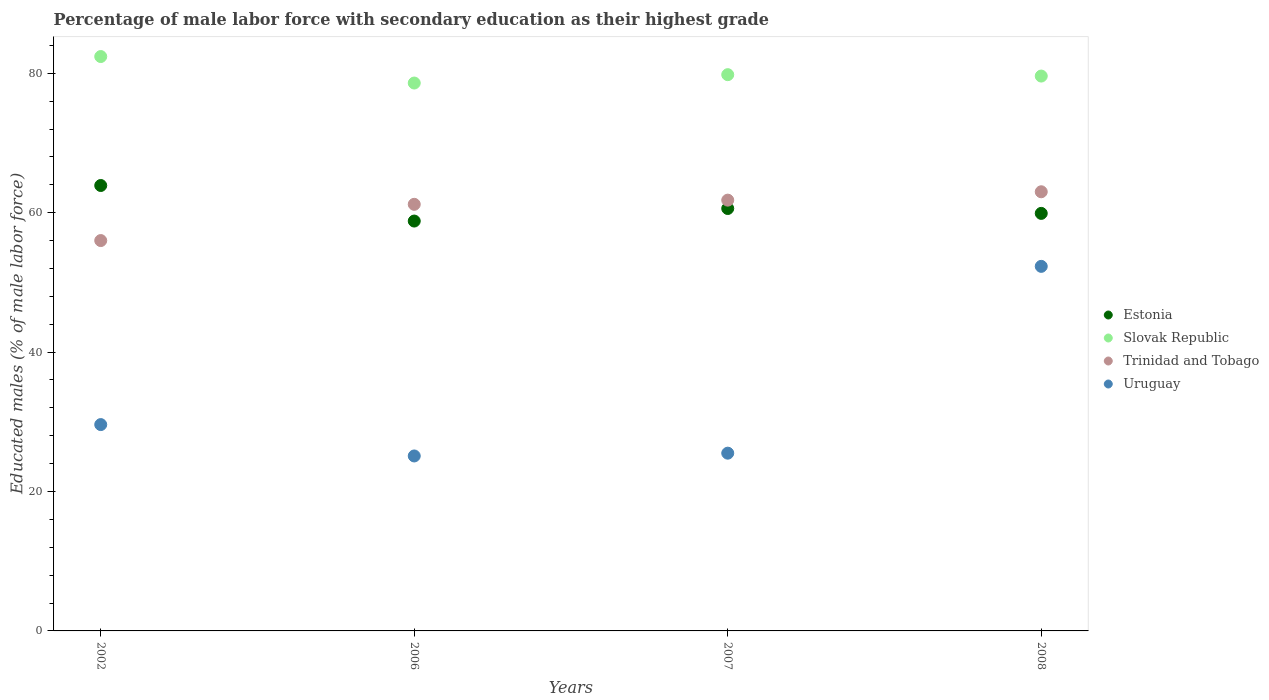How many different coloured dotlines are there?
Your response must be concise. 4. Is the number of dotlines equal to the number of legend labels?
Provide a short and direct response. Yes. What is the percentage of male labor force with secondary education in Uruguay in 2006?
Your response must be concise. 25.1. Across all years, what is the maximum percentage of male labor force with secondary education in Slovak Republic?
Give a very brief answer. 82.4. Across all years, what is the minimum percentage of male labor force with secondary education in Slovak Republic?
Make the answer very short. 78.6. In which year was the percentage of male labor force with secondary education in Trinidad and Tobago minimum?
Provide a short and direct response. 2002. What is the total percentage of male labor force with secondary education in Trinidad and Tobago in the graph?
Provide a short and direct response. 242. What is the difference between the percentage of male labor force with secondary education in Slovak Republic in 2002 and that in 2008?
Your response must be concise. 2.8. What is the difference between the percentage of male labor force with secondary education in Slovak Republic in 2006 and the percentage of male labor force with secondary education in Trinidad and Tobago in 2002?
Keep it short and to the point. 22.6. What is the average percentage of male labor force with secondary education in Uruguay per year?
Provide a short and direct response. 33.12. In the year 2007, what is the difference between the percentage of male labor force with secondary education in Slovak Republic and percentage of male labor force with secondary education in Estonia?
Make the answer very short. 19.2. In how many years, is the percentage of male labor force with secondary education in Estonia greater than 56 %?
Your answer should be very brief. 4. What is the ratio of the percentage of male labor force with secondary education in Uruguay in 2006 to that in 2007?
Ensure brevity in your answer.  0.98. Is the percentage of male labor force with secondary education in Trinidad and Tobago in 2002 less than that in 2008?
Ensure brevity in your answer.  Yes. Is the difference between the percentage of male labor force with secondary education in Slovak Republic in 2002 and 2007 greater than the difference between the percentage of male labor force with secondary education in Estonia in 2002 and 2007?
Provide a short and direct response. No. What is the difference between the highest and the second highest percentage of male labor force with secondary education in Trinidad and Tobago?
Make the answer very short. 1.2. What is the difference between the highest and the lowest percentage of male labor force with secondary education in Estonia?
Provide a succinct answer. 5.1. Is it the case that in every year, the sum of the percentage of male labor force with secondary education in Estonia and percentage of male labor force with secondary education in Trinidad and Tobago  is greater than the sum of percentage of male labor force with secondary education in Slovak Republic and percentage of male labor force with secondary education in Uruguay?
Keep it short and to the point. No. Is the percentage of male labor force with secondary education in Uruguay strictly less than the percentage of male labor force with secondary education in Estonia over the years?
Give a very brief answer. Yes. What is the difference between two consecutive major ticks on the Y-axis?
Provide a succinct answer. 20. Does the graph contain any zero values?
Your response must be concise. No. Does the graph contain grids?
Your response must be concise. No. Where does the legend appear in the graph?
Keep it short and to the point. Center right. How many legend labels are there?
Make the answer very short. 4. How are the legend labels stacked?
Provide a short and direct response. Vertical. What is the title of the graph?
Ensure brevity in your answer.  Percentage of male labor force with secondary education as their highest grade. What is the label or title of the Y-axis?
Keep it short and to the point. Educated males (% of male labor force). What is the Educated males (% of male labor force) in Estonia in 2002?
Your response must be concise. 63.9. What is the Educated males (% of male labor force) in Slovak Republic in 2002?
Your response must be concise. 82.4. What is the Educated males (% of male labor force) in Uruguay in 2002?
Give a very brief answer. 29.6. What is the Educated males (% of male labor force) in Estonia in 2006?
Your response must be concise. 58.8. What is the Educated males (% of male labor force) of Slovak Republic in 2006?
Provide a succinct answer. 78.6. What is the Educated males (% of male labor force) of Trinidad and Tobago in 2006?
Offer a very short reply. 61.2. What is the Educated males (% of male labor force) in Uruguay in 2006?
Offer a very short reply. 25.1. What is the Educated males (% of male labor force) in Estonia in 2007?
Offer a very short reply. 60.6. What is the Educated males (% of male labor force) of Slovak Republic in 2007?
Offer a very short reply. 79.8. What is the Educated males (% of male labor force) of Trinidad and Tobago in 2007?
Offer a terse response. 61.8. What is the Educated males (% of male labor force) in Uruguay in 2007?
Ensure brevity in your answer.  25.5. What is the Educated males (% of male labor force) of Estonia in 2008?
Offer a very short reply. 59.9. What is the Educated males (% of male labor force) in Slovak Republic in 2008?
Provide a succinct answer. 79.6. What is the Educated males (% of male labor force) in Trinidad and Tobago in 2008?
Give a very brief answer. 63. What is the Educated males (% of male labor force) of Uruguay in 2008?
Make the answer very short. 52.3. Across all years, what is the maximum Educated males (% of male labor force) of Estonia?
Give a very brief answer. 63.9. Across all years, what is the maximum Educated males (% of male labor force) in Slovak Republic?
Give a very brief answer. 82.4. Across all years, what is the maximum Educated males (% of male labor force) in Uruguay?
Provide a short and direct response. 52.3. Across all years, what is the minimum Educated males (% of male labor force) of Estonia?
Provide a short and direct response. 58.8. Across all years, what is the minimum Educated males (% of male labor force) of Slovak Republic?
Your answer should be compact. 78.6. Across all years, what is the minimum Educated males (% of male labor force) of Uruguay?
Your answer should be very brief. 25.1. What is the total Educated males (% of male labor force) of Estonia in the graph?
Provide a succinct answer. 243.2. What is the total Educated males (% of male labor force) of Slovak Republic in the graph?
Make the answer very short. 320.4. What is the total Educated males (% of male labor force) in Trinidad and Tobago in the graph?
Provide a succinct answer. 242. What is the total Educated males (% of male labor force) in Uruguay in the graph?
Offer a terse response. 132.5. What is the difference between the Educated males (% of male labor force) of Slovak Republic in 2002 and that in 2007?
Provide a succinct answer. 2.6. What is the difference between the Educated males (% of male labor force) in Uruguay in 2002 and that in 2007?
Your answer should be compact. 4.1. What is the difference between the Educated males (% of male labor force) in Slovak Republic in 2002 and that in 2008?
Provide a short and direct response. 2.8. What is the difference between the Educated males (% of male labor force) of Uruguay in 2002 and that in 2008?
Your response must be concise. -22.7. What is the difference between the Educated males (% of male labor force) in Estonia in 2006 and that in 2007?
Ensure brevity in your answer.  -1.8. What is the difference between the Educated males (% of male labor force) in Slovak Republic in 2006 and that in 2007?
Give a very brief answer. -1.2. What is the difference between the Educated males (% of male labor force) of Estonia in 2006 and that in 2008?
Make the answer very short. -1.1. What is the difference between the Educated males (% of male labor force) in Trinidad and Tobago in 2006 and that in 2008?
Provide a succinct answer. -1.8. What is the difference between the Educated males (% of male labor force) of Uruguay in 2006 and that in 2008?
Your answer should be very brief. -27.2. What is the difference between the Educated males (% of male labor force) in Slovak Republic in 2007 and that in 2008?
Offer a very short reply. 0.2. What is the difference between the Educated males (% of male labor force) in Trinidad and Tobago in 2007 and that in 2008?
Provide a succinct answer. -1.2. What is the difference between the Educated males (% of male labor force) of Uruguay in 2007 and that in 2008?
Make the answer very short. -26.8. What is the difference between the Educated males (% of male labor force) of Estonia in 2002 and the Educated males (% of male labor force) of Slovak Republic in 2006?
Provide a short and direct response. -14.7. What is the difference between the Educated males (% of male labor force) in Estonia in 2002 and the Educated males (% of male labor force) in Trinidad and Tobago in 2006?
Offer a very short reply. 2.7. What is the difference between the Educated males (% of male labor force) in Estonia in 2002 and the Educated males (% of male labor force) in Uruguay in 2006?
Provide a short and direct response. 38.8. What is the difference between the Educated males (% of male labor force) in Slovak Republic in 2002 and the Educated males (% of male labor force) in Trinidad and Tobago in 2006?
Keep it short and to the point. 21.2. What is the difference between the Educated males (% of male labor force) of Slovak Republic in 2002 and the Educated males (% of male labor force) of Uruguay in 2006?
Your response must be concise. 57.3. What is the difference between the Educated males (% of male labor force) in Trinidad and Tobago in 2002 and the Educated males (% of male labor force) in Uruguay in 2006?
Ensure brevity in your answer.  30.9. What is the difference between the Educated males (% of male labor force) of Estonia in 2002 and the Educated males (% of male labor force) of Slovak Republic in 2007?
Ensure brevity in your answer.  -15.9. What is the difference between the Educated males (% of male labor force) in Estonia in 2002 and the Educated males (% of male labor force) in Uruguay in 2007?
Make the answer very short. 38.4. What is the difference between the Educated males (% of male labor force) in Slovak Republic in 2002 and the Educated males (% of male labor force) in Trinidad and Tobago in 2007?
Your answer should be very brief. 20.6. What is the difference between the Educated males (% of male labor force) in Slovak Republic in 2002 and the Educated males (% of male labor force) in Uruguay in 2007?
Your response must be concise. 56.9. What is the difference between the Educated males (% of male labor force) in Trinidad and Tobago in 2002 and the Educated males (% of male labor force) in Uruguay in 2007?
Your response must be concise. 30.5. What is the difference between the Educated males (% of male labor force) of Estonia in 2002 and the Educated males (% of male labor force) of Slovak Republic in 2008?
Offer a terse response. -15.7. What is the difference between the Educated males (% of male labor force) in Estonia in 2002 and the Educated males (% of male labor force) in Trinidad and Tobago in 2008?
Your answer should be very brief. 0.9. What is the difference between the Educated males (% of male labor force) in Estonia in 2002 and the Educated males (% of male labor force) in Uruguay in 2008?
Your answer should be compact. 11.6. What is the difference between the Educated males (% of male labor force) of Slovak Republic in 2002 and the Educated males (% of male labor force) of Uruguay in 2008?
Your response must be concise. 30.1. What is the difference between the Educated males (% of male labor force) of Trinidad and Tobago in 2002 and the Educated males (% of male labor force) of Uruguay in 2008?
Make the answer very short. 3.7. What is the difference between the Educated males (% of male labor force) in Estonia in 2006 and the Educated males (% of male labor force) in Slovak Republic in 2007?
Make the answer very short. -21. What is the difference between the Educated males (% of male labor force) in Estonia in 2006 and the Educated males (% of male labor force) in Trinidad and Tobago in 2007?
Offer a terse response. -3. What is the difference between the Educated males (% of male labor force) of Estonia in 2006 and the Educated males (% of male labor force) of Uruguay in 2007?
Your answer should be very brief. 33.3. What is the difference between the Educated males (% of male labor force) in Slovak Republic in 2006 and the Educated males (% of male labor force) in Trinidad and Tobago in 2007?
Offer a very short reply. 16.8. What is the difference between the Educated males (% of male labor force) in Slovak Republic in 2006 and the Educated males (% of male labor force) in Uruguay in 2007?
Offer a very short reply. 53.1. What is the difference between the Educated males (% of male labor force) in Trinidad and Tobago in 2006 and the Educated males (% of male labor force) in Uruguay in 2007?
Give a very brief answer. 35.7. What is the difference between the Educated males (% of male labor force) in Estonia in 2006 and the Educated males (% of male labor force) in Slovak Republic in 2008?
Provide a succinct answer. -20.8. What is the difference between the Educated males (% of male labor force) in Estonia in 2006 and the Educated males (% of male labor force) in Uruguay in 2008?
Give a very brief answer. 6.5. What is the difference between the Educated males (% of male labor force) of Slovak Republic in 2006 and the Educated males (% of male labor force) of Trinidad and Tobago in 2008?
Ensure brevity in your answer.  15.6. What is the difference between the Educated males (% of male labor force) in Slovak Republic in 2006 and the Educated males (% of male labor force) in Uruguay in 2008?
Ensure brevity in your answer.  26.3. What is the difference between the Educated males (% of male labor force) of Trinidad and Tobago in 2006 and the Educated males (% of male labor force) of Uruguay in 2008?
Ensure brevity in your answer.  8.9. What is the difference between the Educated males (% of male labor force) in Estonia in 2007 and the Educated males (% of male labor force) in Slovak Republic in 2008?
Ensure brevity in your answer.  -19. What is the difference between the Educated males (% of male labor force) of Estonia in 2007 and the Educated males (% of male labor force) of Trinidad and Tobago in 2008?
Keep it short and to the point. -2.4. What is the difference between the Educated males (% of male labor force) of Estonia in 2007 and the Educated males (% of male labor force) of Uruguay in 2008?
Offer a very short reply. 8.3. What is the difference between the Educated males (% of male labor force) of Slovak Republic in 2007 and the Educated males (% of male labor force) of Trinidad and Tobago in 2008?
Your answer should be compact. 16.8. What is the difference between the Educated males (% of male labor force) in Slovak Republic in 2007 and the Educated males (% of male labor force) in Uruguay in 2008?
Ensure brevity in your answer.  27.5. What is the average Educated males (% of male labor force) of Estonia per year?
Give a very brief answer. 60.8. What is the average Educated males (% of male labor force) in Slovak Republic per year?
Provide a short and direct response. 80.1. What is the average Educated males (% of male labor force) in Trinidad and Tobago per year?
Your response must be concise. 60.5. What is the average Educated males (% of male labor force) of Uruguay per year?
Your answer should be very brief. 33.12. In the year 2002, what is the difference between the Educated males (% of male labor force) in Estonia and Educated males (% of male labor force) in Slovak Republic?
Offer a very short reply. -18.5. In the year 2002, what is the difference between the Educated males (% of male labor force) of Estonia and Educated males (% of male labor force) of Uruguay?
Your answer should be very brief. 34.3. In the year 2002, what is the difference between the Educated males (% of male labor force) in Slovak Republic and Educated males (% of male labor force) in Trinidad and Tobago?
Make the answer very short. 26.4. In the year 2002, what is the difference between the Educated males (% of male labor force) of Slovak Republic and Educated males (% of male labor force) of Uruguay?
Your answer should be compact. 52.8. In the year 2002, what is the difference between the Educated males (% of male labor force) of Trinidad and Tobago and Educated males (% of male labor force) of Uruguay?
Keep it short and to the point. 26.4. In the year 2006, what is the difference between the Educated males (% of male labor force) in Estonia and Educated males (% of male labor force) in Slovak Republic?
Ensure brevity in your answer.  -19.8. In the year 2006, what is the difference between the Educated males (% of male labor force) of Estonia and Educated males (% of male labor force) of Trinidad and Tobago?
Your response must be concise. -2.4. In the year 2006, what is the difference between the Educated males (% of male labor force) in Estonia and Educated males (% of male labor force) in Uruguay?
Make the answer very short. 33.7. In the year 2006, what is the difference between the Educated males (% of male labor force) in Slovak Republic and Educated males (% of male labor force) in Uruguay?
Give a very brief answer. 53.5. In the year 2006, what is the difference between the Educated males (% of male labor force) in Trinidad and Tobago and Educated males (% of male labor force) in Uruguay?
Keep it short and to the point. 36.1. In the year 2007, what is the difference between the Educated males (% of male labor force) of Estonia and Educated males (% of male labor force) of Slovak Republic?
Your response must be concise. -19.2. In the year 2007, what is the difference between the Educated males (% of male labor force) in Estonia and Educated males (% of male labor force) in Uruguay?
Your answer should be compact. 35.1. In the year 2007, what is the difference between the Educated males (% of male labor force) of Slovak Republic and Educated males (% of male labor force) of Uruguay?
Provide a succinct answer. 54.3. In the year 2007, what is the difference between the Educated males (% of male labor force) of Trinidad and Tobago and Educated males (% of male labor force) of Uruguay?
Provide a short and direct response. 36.3. In the year 2008, what is the difference between the Educated males (% of male labor force) in Estonia and Educated males (% of male labor force) in Slovak Republic?
Ensure brevity in your answer.  -19.7. In the year 2008, what is the difference between the Educated males (% of male labor force) in Estonia and Educated males (% of male labor force) in Trinidad and Tobago?
Your response must be concise. -3.1. In the year 2008, what is the difference between the Educated males (% of male labor force) of Slovak Republic and Educated males (% of male labor force) of Uruguay?
Provide a succinct answer. 27.3. What is the ratio of the Educated males (% of male labor force) in Estonia in 2002 to that in 2006?
Give a very brief answer. 1.09. What is the ratio of the Educated males (% of male labor force) in Slovak Republic in 2002 to that in 2006?
Your answer should be compact. 1.05. What is the ratio of the Educated males (% of male labor force) in Trinidad and Tobago in 2002 to that in 2006?
Make the answer very short. 0.92. What is the ratio of the Educated males (% of male labor force) in Uruguay in 2002 to that in 2006?
Ensure brevity in your answer.  1.18. What is the ratio of the Educated males (% of male labor force) in Estonia in 2002 to that in 2007?
Make the answer very short. 1.05. What is the ratio of the Educated males (% of male labor force) of Slovak Republic in 2002 to that in 2007?
Make the answer very short. 1.03. What is the ratio of the Educated males (% of male labor force) in Trinidad and Tobago in 2002 to that in 2007?
Give a very brief answer. 0.91. What is the ratio of the Educated males (% of male labor force) of Uruguay in 2002 to that in 2007?
Provide a succinct answer. 1.16. What is the ratio of the Educated males (% of male labor force) of Estonia in 2002 to that in 2008?
Make the answer very short. 1.07. What is the ratio of the Educated males (% of male labor force) in Slovak Republic in 2002 to that in 2008?
Your response must be concise. 1.04. What is the ratio of the Educated males (% of male labor force) of Uruguay in 2002 to that in 2008?
Your answer should be very brief. 0.57. What is the ratio of the Educated males (% of male labor force) in Estonia in 2006 to that in 2007?
Offer a terse response. 0.97. What is the ratio of the Educated males (% of male labor force) of Trinidad and Tobago in 2006 to that in 2007?
Keep it short and to the point. 0.99. What is the ratio of the Educated males (% of male labor force) in Uruguay in 2006 to that in 2007?
Your response must be concise. 0.98. What is the ratio of the Educated males (% of male labor force) of Estonia in 2006 to that in 2008?
Offer a terse response. 0.98. What is the ratio of the Educated males (% of male labor force) in Slovak Republic in 2006 to that in 2008?
Provide a short and direct response. 0.99. What is the ratio of the Educated males (% of male labor force) in Trinidad and Tobago in 2006 to that in 2008?
Offer a terse response. 0.97. What is the ratio of the Educated males (% of male labor force) of Uruguay in 2006 to that in 2008?
Provide a succinct answer. 0.48. What is the ratio of the Educated males (% of male labor force) in Estonia in 2007 to that in 2008?
Make the answer very short. 1.01. What is the ratio of the Educated males (% of male labor force) of Uruguay in 2007 to that in 2008?
Offer a very short reply. 0.49. What is the difference between the highest and the second highest Educated males (% of male labor force) in Trinidad and Tobago?
Keep it short and to the point. 1.2. What is the difference between the highest and the second highest Educated males (% of male labor force) in Uruguay?
Offer a very short reply. 22.7. What is the difference between the highest and the lowest Educated males (% of male labor force) in Estonia?
Ensure brevity in your answer.  5.1. What is the difference between the highest and the lowest Educated males (% of male labor force) of Trinidad and Tobago?
Provide a succinct answer. 7. What is the difference between the highest and the lowest Educated males (% of male labor force) in Uruguay?
Your answer should be very brief. 27.2. 